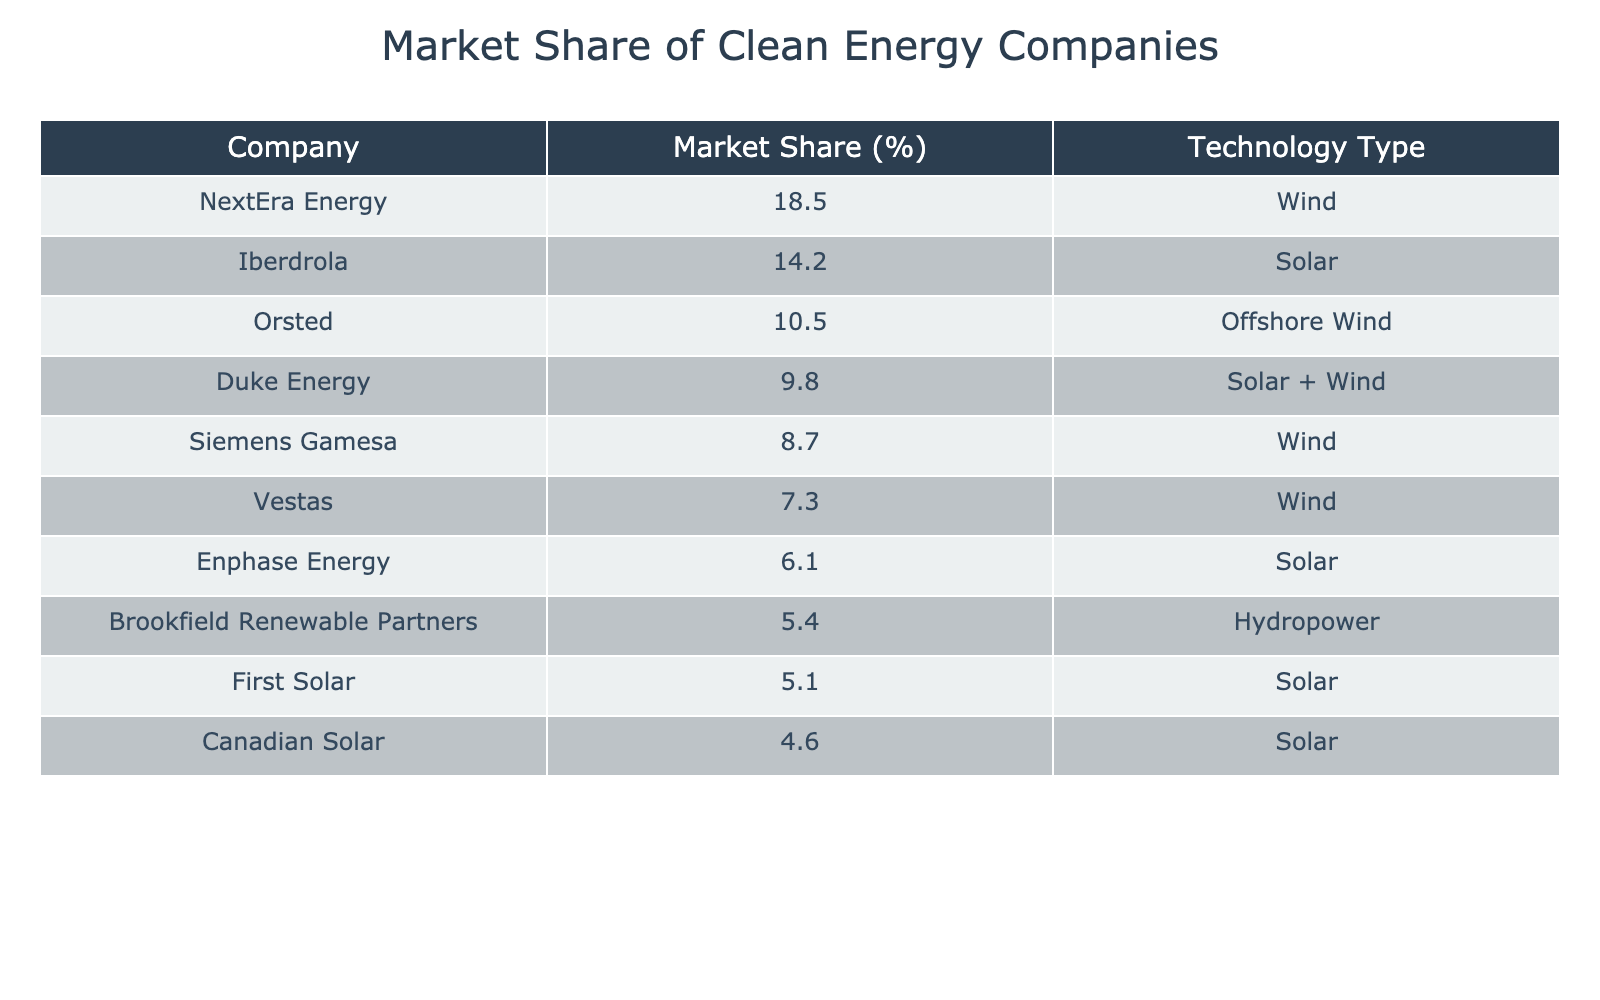What company has the largest market share in the clean energy sector? By looking at the table, we identify the company with the highest percentage in the "Market Share (%)" column. NextEra Energy is listed as having 18.5%, which is greater than any other percentage in the table.
Answer: NextEra Energy How much market share do the top three companies collectively hold? The top three companies based on market share are NextEra Energy (18.5%), Iberdrola (14.2%), and Orsted (10.5%). Adding these values together: 18.5 + 14.2 + 10.5 = 43.2%.
Answer: 43.2% Is there any company that specializes in offshore wind technology according to the table? Orsted is listed as a company that utilizes offshore wind technology with a market share of 10.5%. This confirms the existence of a specialized company in that technology type.
Answer: Yes What is the percentage difference in market share between Duke Energy and Siemens Gamesa? Duke Energy has a market share of 9.8%, and Siemens Gamesa has 8.7%. To find the difference, subtract Siemens Gamesa's share from Duke Energy's share: 9.8 - 8.7 = 1.1%.
Answer: 1.1% What technology type is most represented among the companies listed? By examining the "Technology Type" column, we see that Wind appears in multiple companies: NextEra Energy, Siemens Gamesa, and Vestas. At least three companies use Wind technology, while other technologies are represented by fewer companies. Thus, Wind is the most represented technology type.
Answer: Wind 